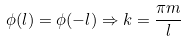Convert formula to latex. <formula><loc_0><loc_0><loc_500><loc_500>\phi ( l ) = \phi ( - l ) \Rightarrow k = \frac { \pi m } { l }</formula> 